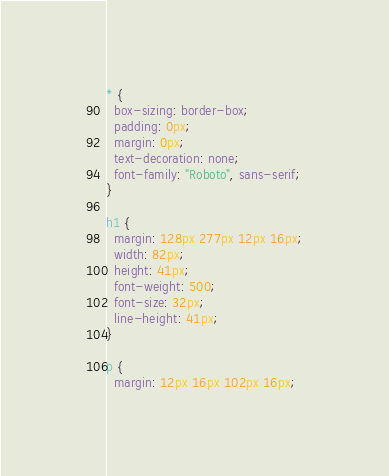<code> <loc_0><loc_0><loc_500><loc_500><_CSS_>* {
  box-sizing: border-box;
  padding: 0px;
  margin: 0px;
  text-decoration: none;
  font-family: "Roboto", sans-serif;
}

h1 {
  margin: 128px 277px 12px 16px;
  width: 82px;
  height: 41px;
  font-weight: 500;
  font-size: 32px;
  line-height: 41px;
}

p {
  margin: 12px 16px 102px 16px;</code> 